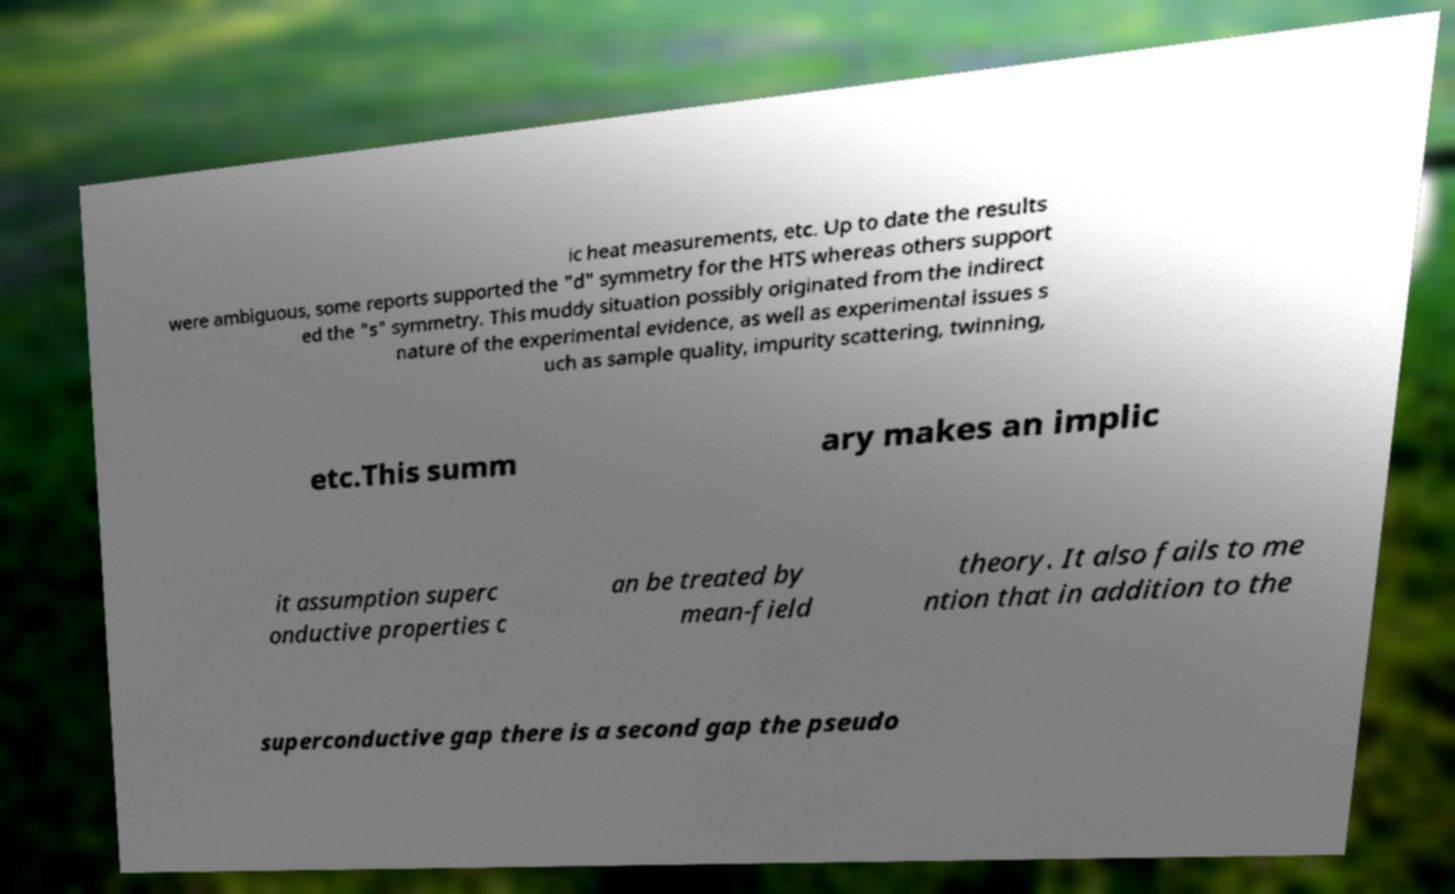There's text embedded in this image that I need extracted. Can you transcribe it verbatim? ic heat measurements, etc. Up to date the results were ambiguous, some reports supported the "d" symmetry for the HTS whereas others support ed the "s" symmetry. This muddy situation possibly originated from the indirect nature of the experimental evidence, as well as experimental issues s uch as sample quality, impurity scattering, twinning, etc.This summ ary makes an implic it assumption superc onductive properties c an be treated by mean-field theory. It also fails to me ntion that in addition to the superconductive gap there is a second gap the pseudo 